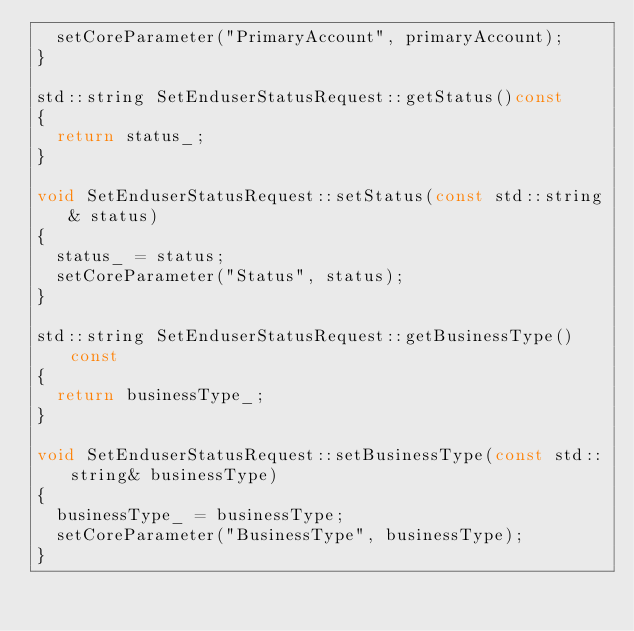Convert code to text. <code><loc_0><loc_0><loc_500><loc_500><_C++_>	setCoreParameter("PrimaryAccount", primaryAccount);
}

std::string SetEnduserStatusRequest::getStatus()const
{
	return status_;
}

void SetEnduserStatusRequest::setStatus(const std::string& status)
{
	status_ = status;
	setCoreParameter("Status", status);
}

std::string SetEnduserStatusRequest::getBusinessType()const
{
	return businessType_;
}

void SetEnduserStatusRequest::setBusinessType(const std::string& businessType)
{
	businessType_ = businessType;
	setCoreParameter("BusinessType", businessType);
}

</code> 